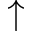<formula> <loc_0><loc_0><loc_500><loc_500>\uparrow</formula> 